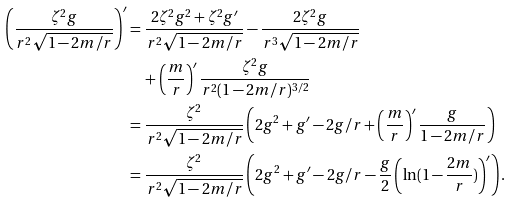Convert formula to latex. <formula><loc_0><loc_0><loc_500><loc_500>\left ( \frac { \zeta ^ { 2 } g } { r ^ { 2 } \sqrt { 1 - 2 m / r } } \right ) ^ { \prime } & = \frac { 2 \zeta ^ { 2 } g ^ { 2 } + \zeta ^ { 2 } g ^ { \prime } } { r ^ { 2 } \sqrt { 1 - 2 m / r } } - \frac { 2 \zeta ^ { 2 } g } { r ^ { 3 } \sqrt { 1 - 2 m / r } } \\ & \quad + \left ( \frac { m } { r } \right ) ^ { \prime } \frac { \zeta ^ { 2 } g } { r ^ { 2 } ( 1 - 2 m / r ) ^ { 3 / 2 } } \\ & = \frac { \zeta ^ { 2 } } { r ^ { 2 } \sqrt { 1 - 2 m / r } } \left ( 2 g ^ { 2 } + g ^ { \prime } - 2 g / r + \left ( \frac { m } { r } \right ) ^ { \prime } \frac { g } { 1 - 2 m / r } \right ) \\ & = \frac { \zeta ^ { 2 } } { r ^ { 2 } \sqrt { 1 - 2 m / r } } \left ( 2 g ^ { 2 } + g ^ { \prime } - 2 g / r - \frac { g } { 2 } \left ( \ln ( 1 - \frac { 2 m } { r } ) \right ) ^ { \prime } \right ) .</formula> 